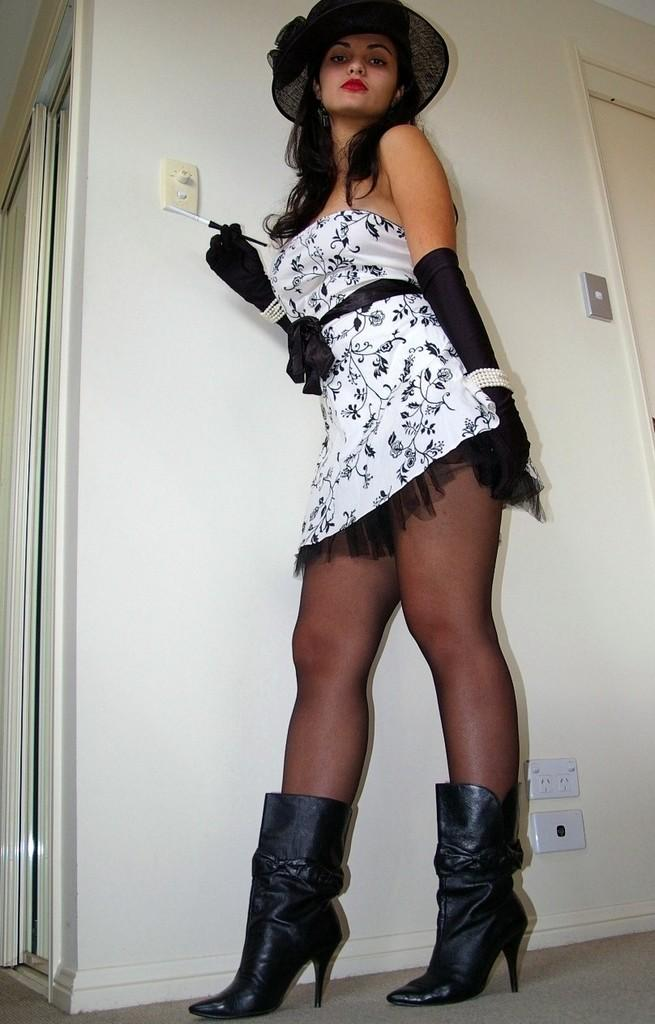Who is the main subject in the image? There is a lady in the image. What is the lady wearing on her head? The lady is wearing a hat. What is the lady holding in the image? The lady is holding an object. What is the lady doing in the image? The lady is posing for a photo. What can be seen behind the lady in the image? There is a wall behind the lady. How many ladybugs are crawling on the lady's hat in the image? There are no ladybugs present in the image; the lady is wearing a hat, but no ladybugs are visible. 